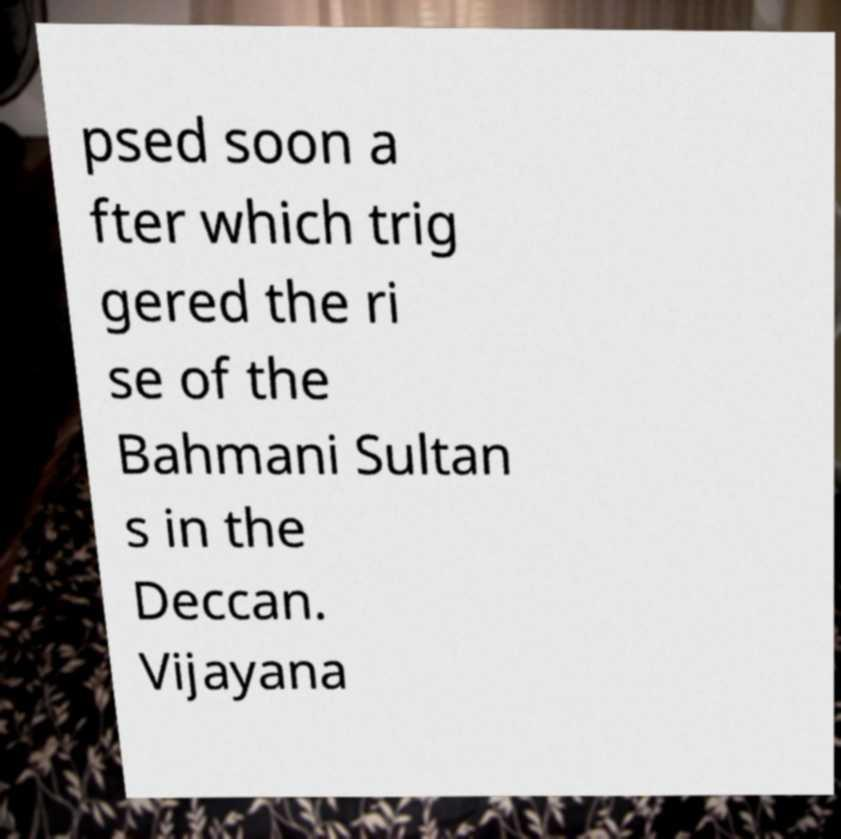Can you read and provide the text displayed in the image?This photo seems to have some interesting text. Can you extract and type it out for me? psed soon a fter which trig gered the ri se of the Bahmani Sultan s in the Deccan. Vijayana 